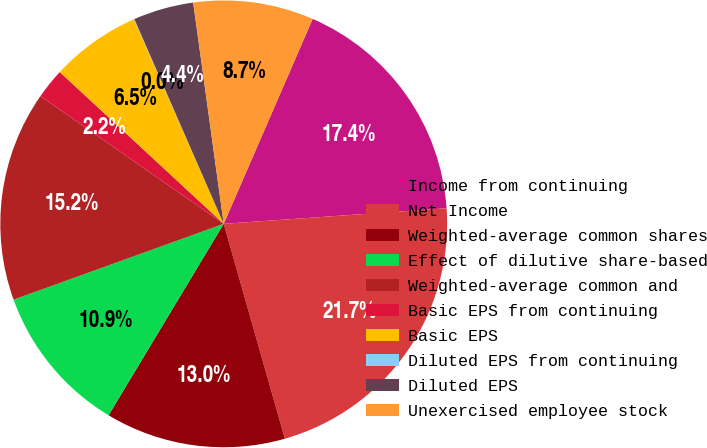<chart> <loc_0><loc_0><loc_500><loc_500><pie_chart><fcel>Income from continuing<fcel>Net Income<fcel>Weighted-average common shares<fcel>Effect of dilutive share-based<fcel>Weighted-average common and<fcel>Basic EPS from continuing<fcel>Basic EPS<fcel>Diluted EPS from continuing<fcel>Diluted EPS<fcel>Unexercised employee stock<nl><fcel>17.37%<fcel>21.7%<fcel>13.03%<fcel>10.87%<fcel>15.2%<fcel>2.2%<fcel>6.53%<fcel>0.03%<fcel>4.37%<fcel>8.7%<nl></chart> 